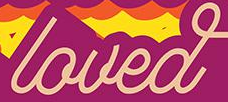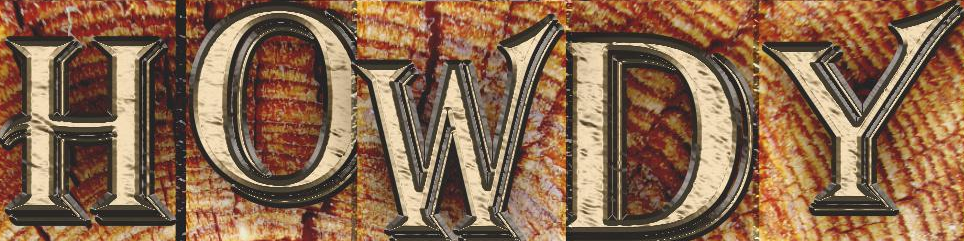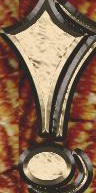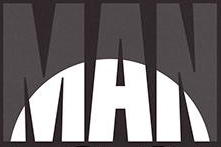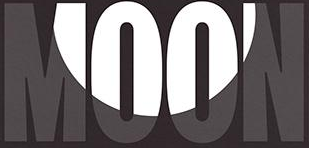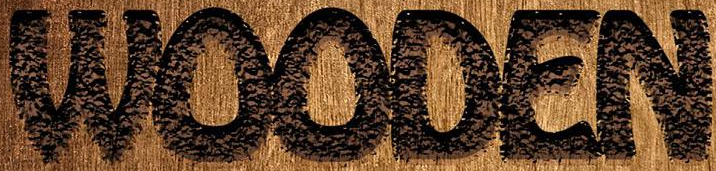What text appears in these images from left to right, separated by a semicolon? loved; HOWDY; !; MAN; MOON; WOODEN 